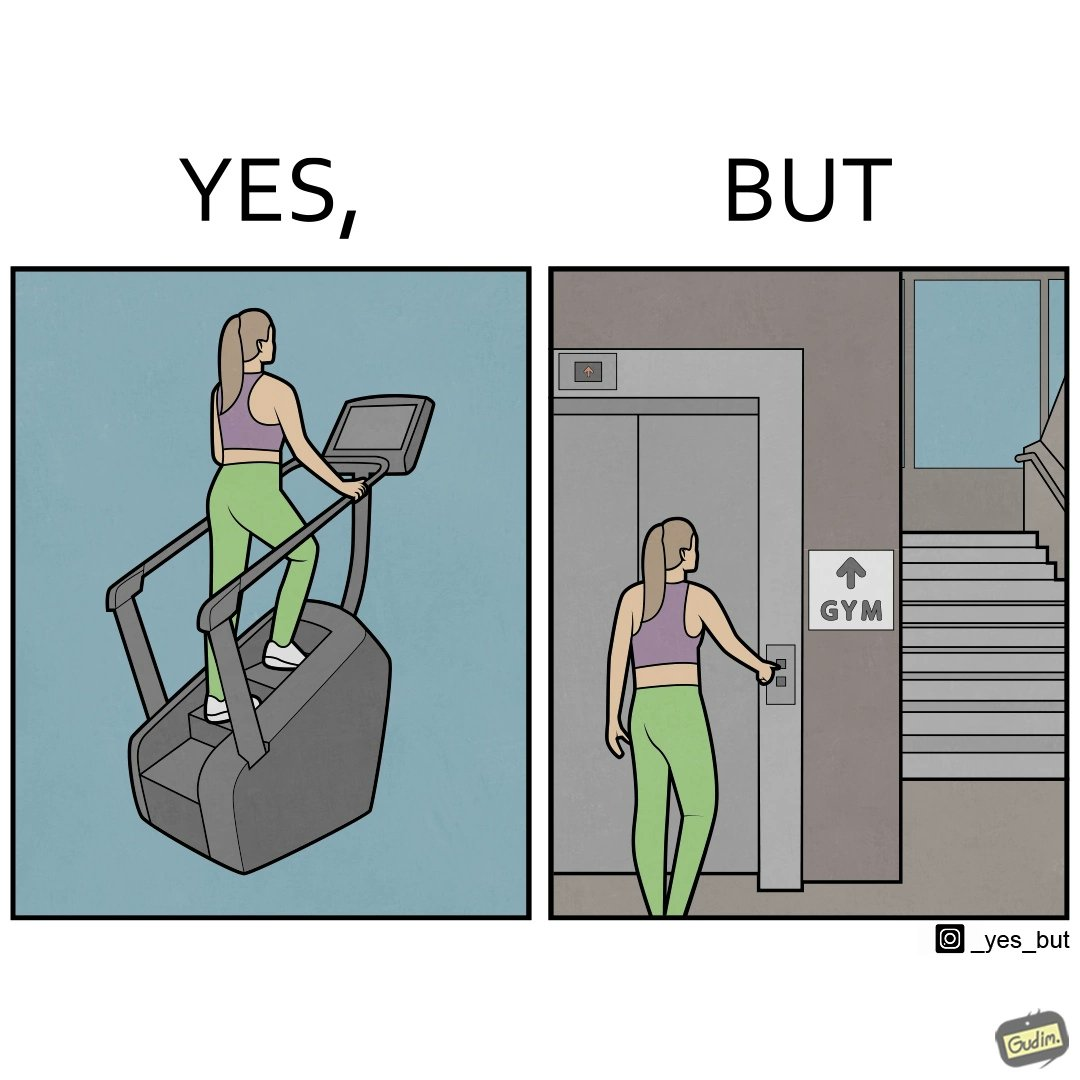Compare the left and right sides of this image. In the left part of the image: a woman is seen using the stair climber machine at some gym In the right part of the image: a woman calling for the lift to avoid climbing up the stairs for going to the gym 